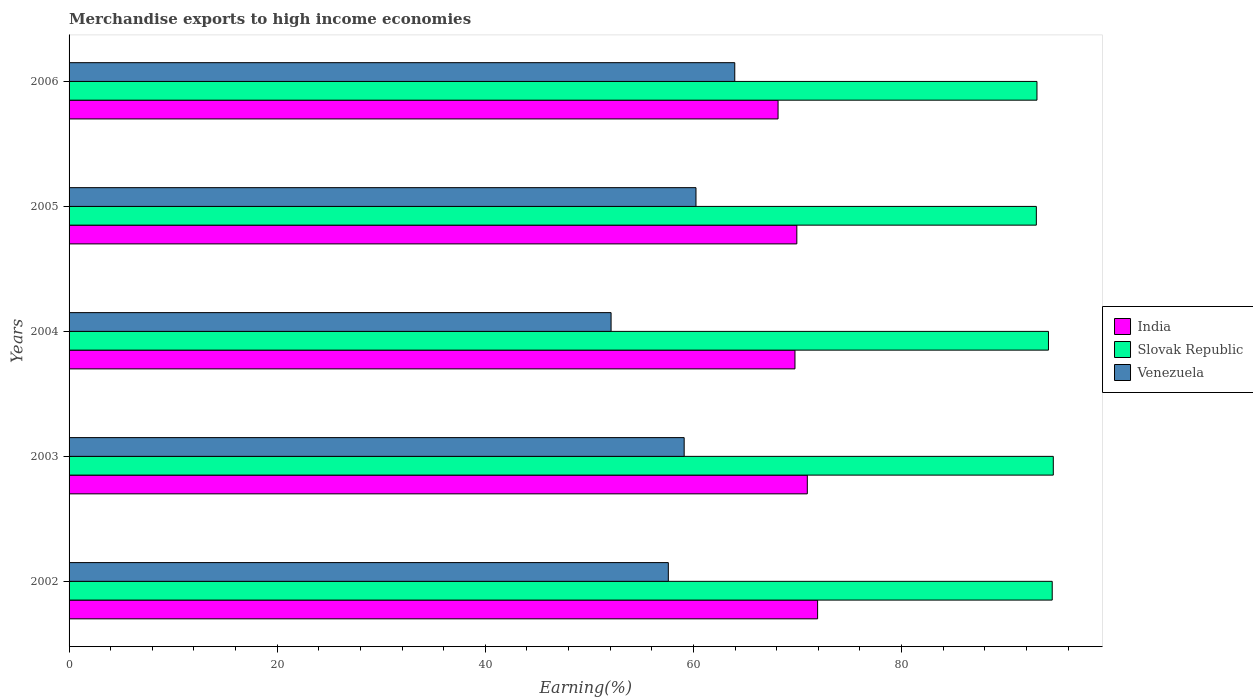Are the number of bars on each tick of the Y-axis equal?
Your answer should be compact. Yes. How many bars are there on the 2nd tick from the top?
Give a very brief answer. 3. What is the percentage of amount earned from merchandise exports in Venezuela in 2002?
Offer a very short reply. 57.59. Across all years, what is the maximum percentage of amount earned from merchandise exports in India?
Your response must be concise. 71.94. Across all years, what is the minimum percentage of amount earned from merchandise exports in Slovak Republic?
Your answer should be very brief. 92.96. What is the total percentage of amount earned from merchandise exports in Venezuela in the graph?
Offer a very short reply. 293.02. What is the difference between the percentage of amount earned from merchandise exports in India in 2003 and that in 2004?
Provide a succinct answer. 1.19. What is the difference between the percentage of amount earned from merchandise exports in Slovak Republic in 2004 and the percentage of amount earned from merchandise exports in Venezuela in 2003?
Your answer should be very brief. 35.01. What is the average percentage of amount earned from merchandise exports in India per year?
Offer a very short reply. 70.14. In the year 2004, what is the difference between the percentage of amount earned from merchandise exports in Slovak Republic and percentage of amount earned from merchandise exports in India?
Offer a terse response. 24.36. In how many years, is the percentage of amount earned from merchandise exports in Venezuela greater than 44 %?
Provide a succinct answer. 5. What is the ratio of the percentage of amount earned from merchandise exports in India in 2002 to that in 2005?
Make the answer very short. 1.03. Is the percentage of amount earned from merchandise exports in Slovak Republic in 2004 less than that in 2006?
Give a very brief answer. No. Is the difference between the percentage of amount earned from merchandise exports in Slovak Republic in 2003 and 2004 greater than the difference between the percentage of amount earned from merchandise exports in India in 2003 and 2004?
Offer a terse response. No. What is the difference between the highest and the second highest percentage of amount earned from merchandise exports in Slovak Republic?
Your response must be concise. 0.1. What is the difference between the highest and the lowest percentage of amount earned from merchandise exports in Slovak Republic?
Make the answer very short. 1.63. In how many years, is the percentage of amount earned from merchandise exports in Venezuela greater than the average percentage of amount earned from merchandise exports in Venezuela taken over all years?
Keep it short and to the point. 3. What does the 2nd bar from the top in 2004 represents?
Keep it short and to the point. Slovak Republic. How many bars are there?
Offer a very short reply. 15. Are all the bars in the graph horizontal?
Ensure brevity in your answer.  Yes. What is the difference between two consecutive major ticks on the X-axis?
Give a very brief answer. 20. Are the values on the major ticks of X-axis written in scientific E-notation?
Provide a succinct answer. No. Does the graph contain any zero values?
Offer a very short reply. No. Does the graph contain grids?
Your answer should be compact. No. How many legend labels are there?
Ensure brevity in your answer.  3. How are the legend labels stacked?
Provide a short and direct response. Vertical. What is the title of the graph?
Keep it short and to the point. Merchandise exports to high income economies. Does "Burundi" appear as one of the legend labels in the graph?
Keep it short and to the point. No. What is the label or title of the X-axis?
Provide a short and direct response. Earning(%). What is the Earning(%) in India in 2002?
Give a very brief answer. 71.94. What is the Earning(%) in Slovak Republic in 2002?
Make the answer very short. 94.48. What is the Earning(%) of Venezuela in 2002?
Your response must be concise. 57.59. What is the Earning(%) of India in 2003?
Your answer should be very brief. 70.95. What is the Earning(%) in Slovak Republic in 2003?
Keep it short and to the point. 94.59. What is the Earning(%) of Venezuela in 2003?
Your answer should be compact. 59.11. What is the Earning(%) of India in 2004?
Provide a succinct answer. 69.76. What is the Earning(%) of Slovak Republic in 2004?
Your answer should be very brief. 94.12. What is the Earning(%) of Venezuela in 2004?
Your answer should be very brief. 52.09. What is the Earning(%) of India in 2005?
Your answer should be very brief. 69.94. What is the Earning(%) in Slovak Republic in 2005?
Offer a very short reply. 92.96. What is the Earning(%) in Venezuela in 2005?
Provide a succinct answer. 60.25. What is the Earning(%) in India in 2006?
Keep it short and to the point. 68.14. What is the Earning(%) of Slovak Republic in 2006?
Your response must be concise. 93.02. What is the Earning(%) in Venezuela in 2006?
Provide a short and direct response. 63.98. Across all years, what is the maximum Earning(%) in India?
Offer a very short reply. 71.94. Across all years, what is the maximum Earning(%) of Slovak Republic?
Provide a short and direct response. 94.59. Across all years, what is the maximum Earning(%) in Venezuela?
Offer a terse response. 63.98. Across all years, what is the minimum Earning(%) of India?
Give a very brief answer. 68.14. Across all years, what is the minimum Earning(%) of Slovak Republic?
Keep it short and to the point. 92.96. Across all years, what is the minimum Earning(%) in Venezuela?
Your answer should be very brief. 52.09. What is the total Earning(%) of India in the graph?
Provide a short and direct response. 350.72. What is the total Earning(%) of Slovak Republic in the graph?
Give a very brief answer. 469.17. What is the total Earning(%) in Venezuela in the graph?
Your answer should be very brief. 293.02. What is the difference between the Earning(%) in India in 2002 and that in 2003?
Ensure brevity in your answer.  0.99. What is the difference between the Earning(%) of Slovak Republic in 2002 and that in 2003?
Your response must be concise. -0.1. What is the difference between the Earning(%) in Venezuela in 2002 and that in 2003?
Offer a terse response. -1.52. What is the difference between the Earning(%) in India in 2002 and that in 2004?
Your response must be concise. 2.18. What is the difference between the Earning(%) of Slovak Republic in 2002 and that in 2004?
Give a very brief answer. 0.36. What is the difference between the Earning(%) of Venezuela in 2002 and that in 2004?
Your response must be concise. 5.5. What is the difference between the Earning(%) of India in 2002 and that in 2005?
Offer a very short reply. 2. What is the difference between the Earning(%) of Slovak Republic in 2002 and that in 2005?
Provide a succinct answer. 1.53. What is the difference between the Earning(%) of Venezuela in 2002 and that in 2005?
Give a very brief answer. -2.66. What is the difference between the Earning(%) of India in 2002 and that in 2006?
Offer a very short reply. 3.8. What is the difference between the Earning(%) in Slovak Republic in 2002 and that in 2006?
Your answer should be compact. 1.47. What is the difference between the Earning(%) in Venezuela in 2002 and that in 2006?
Ensure brevity in your answer.  -6.39. What is the difference between the Earning(%) in India in 2003 and that in 2004?
Your response must be concise. 1.19. What is the difference between the Earning(%) in Slovak Republic in 2003 and that in 2004?
Ensure brevity in your answer.  0.46. What is the difference between the Earning(%) of Venezuela in 2003 and that in 2004?
Make the answer very short. 7.03. What is the difference between the Earning(%) of India in 2003 and that in 2005?
Provide a succinct answer. 1.01. What is the difference between the Earning(%) of Slovak Republic in 2003 and that in 2005?
Ensure brevity in your answer.  1.63. What is the difference between the Earning(%) in Venezuela in 2003 and that in 2005?
Keep it short and to the point. -1.13. What is the difference between the Earning(%) of India in 2003 and that in 2006?
Make the answer very short. 2.81. What is the difference between the Earning(%) in Slovak Republic in 2003 and that in 2006?
Keep it short and to the point. 1.57. What is the difference between the Earning(%) in Venezuela in 2003 and that in 2006?
Your answer should be compact. -4.86. What is the difference between the Earning(%) in India in 2004 and that in 2005?
Your answer should be compact. -0.18. What is the difference between the Earning(%) in Slovak Republic in 2004 and that in 2005?
Ensure brevity in your answer.  1.17. What is the difference between the Earning(%) in Venezuela in 2004 and that in 2005?
Your answer should be compact. -8.16. What is the difference between the Earning(%) of India in 2004 and that in 2006?
Your response must be concise. 1.62. What is the difference between the Earning(%) in Slovak Republic in 2004 and that in 2006?
Make the answer very short. 1.1. What is the difference between the Earning(%) in Venezuela in 2004 and that in 2006?
Ensure brevity in your answer.  -11.89. What is the difference between the Earning(%) in India in 2005 and that in 2006?
Keep it short and to the point. 1.8. What is the difference between the Earning(%) of Slovak Republic in 2005 and that in 2006?
Give a very brief answer. -0.06. What is the difference between the Earning(%) of Venezuela in 2005 and that in 2006?
Provide a short and direct response. -3.73. What is the difference between the Earning(%) of India in 2002 and the Earning(%) of Slovak Republic in 2003?
Keep it short and to the point. -22.65. What is the difference between the Earning(%) of India in 2002 and the Earning(%) of Venezuela in 2003?
Provide a succinct answer. 12.82. What is the difference between the Earning(%) of Slovak Republic in 2002 and the Earning(%) of Venezuela in 2003?
Provide a short and direct response. 35.37. What is the difference between the Earning(%) in India in 2002 and the Earning(%) in Slovak Republic in 2004?
Make the answer very short. -22.19. What is the difference between the Earning(%) of India in 2002 and the Earning(%) of Venezuela in 2004?
Provide a short and direct response. 19.85. What is the difference between the Earning(%) in Slovak Republic in 2002 and the Earning(%) in Venezuela in 2004?
Your answer should be compact. 42.4. What is the difference between the Earning(%) of India in 2002 and the Earning(%) of Slovak Republic in 2005?
Offer a very short reply. -21.02. What is the difference between the Earning(%) in India in 2002 and the Earning(%) in Venezuela in 2005?
Offer a very short reply. 11.69. What is the difference between the Earning(%) in Slovak Republic in 2002 and the Earning(%) in Venezuela in 2005?
Provide a succinct answer. 34.24. What is the difference between the Earning(%) of India in 2002 and the Earning(%) of Slovak Republic in 2006?
Provide a short and direct response. -21.08. What is the difference between the Earning(%) of India in 2002 and the Earning(%) of Venezuela in 2006?
Offer a very short reply. 7.96. What is the difference between the Earning(%) of Slovak Republic in 2002 and the Earning(%) of Venezuela in 2006?
Ensure brevity in your answer.  30.51. What is the difference between the Earning(%) in India in 2003 and the Earning(%) in Slovak Republic in 2004?
Provide a succinct answer. -23.18. What is the difference between the Earning(%) of India in 2003 and the Earning(%) of Venezuela in 2004?
Make the answer very short. 18.86. What is the difference between the Earning(%) in Slovak Republic in 2003 and the Earning(%) in Venezuela in 2004?
Make the answer very short. 42.5. What is the difference between the Earning(%) in India in 2003 and the Earning(%) in Slovak Republic in 2005?
Your response must be concise. -22.01. What is the difference between the Earning(%) in India in 2003 and the Earning(%) in Venezuela in 2005?
Provide a short and direct response. 10.7. What is the difference between the Earning(%) in Slovak Republic in 2003 and the Earning(%) in Venezuela in 2005?
Give a very brief answer. 34.34. What is the difference between the Earning(%) of India in 2003 and the Earning(%) of Slovak Republic in 2006?
Offer a terse response. -22.07. What is the difference between the Earning(%) of India in 2003 and the Earning(%) of Venezuela in 2006?
Offer a very short reply. 6.97. What is the difference between the Earning(%) of Slovak Republic in 2003 and the Earning(%) of Venezuela in 2006?
Give a very brief answer. 30.61. What is the difference between the Earning(%) of India in 2004 and the Earning(%) of Slovak Republic in 2005?
Make the answer very short. -23.2. What is the difference between the Earning(%) of India in 2004 and the Earning(%) of Venezuela in 2005?
Ensure brevity in your answer.  9.51. What is the difference between the Earning(%) of Slovak Republic in 2004 and the Earning(%) of Venezuela in 2005?
Offer a very short reply. 33.88. What is the difference between the Earning(%) in India in 2004 and the Earning(%) in Slovak Republic in 2006?
Keep it short and to the point. -23.26. What is the difference between the Earning(%) of India in 2004 and the Earning(%) of Venezuela in 2006?
Your answer should be compact. 5.78. What is the difference between the Earning(%) of Slovak Republic in 2004 and the Earning(%) of Venezuela in 2006?
Offer a terse response. 30.15. What is the difference between the Earning(%) of India in 2005 and the Earning(%) of Slovak Republic in 2006?
Give a very brief answer. -23.08. What is the difference between the Earning(%) of India in 2005 and the Earning(%) of Venezuela in 2006?
Your answer should be very brief. 5.96. What is the difference between the Earning(%) of Slovak Republic in 2005 and the Earning(%) of Venezuela in 2006?
Give a very brief answer. 28.98. What is the average Earning(%) in India per year?
Give a very brief answer. 70.14. What is the average Earning(%) of Slovak Republic per year?
Your answer should be very brief. 93.83. What is the average Earning(%) in Venezuela per year?
Your answer should be very brief. 58.6. In the year 2002, what is the difference between the Earning(%) in India and Earning(%) in Slovak Republic?
Provide a short and direct response. -22.55. In the year 2002, what is the difference between the Earning(%) in India and Earning(%) in Venezuela?
Offer a terse response. 14.35. In the year 2002, what is the difference between the Earning(%) in Slovak Republic and Earning(%) in Venezuela?
Provide a short and direct response. 36.89. In the year 2003, what is the difference between the Earning(%) in India and Earning(%) in Slovak Republic?
Give a very brief answer. -23.64. In the year 2003, what is the difference between the Earning(%) in India and Earning(%) in Venezuela?
Keep it short and to the point. 11.83. In the year 2003, what is the difference between the Earning(%) of Slovak Republic and Earning(%) of Venezuela?
Your answer should be very brief. 35.47. In the year 2004, what is the difference between the Earning(%) of India and Earning(%) of Slovak Republic?
Provide a short and direct response. -24.36. In the year 2004, what is the difference between the Earning(%) in India and Earning(%) in Venezuela?
Your answer should be compact. 17.67. In the year 2004, what is the difference between the Earning(%) of Slovak Republic and Earning(%) of Venezuela?
Offer a terse response. 42.03. In the year 2005, what is the difference between the Earning(%) in India and Earning(%) in Slovak Republic?
Your response must be concise. -23.02. In the year 2005, what is the difference between the Earning(%) in India and Earning(%) in Venezuela?
Provide a short and direct response. 9.69. In the year 2005, what is the difference between the Earning(%) of Slovak Republic and Earning(%) of Venezuela?
Provide a short and direct response. 32.71. In the year 2006, what is the difference between the Earning(%) in India and Earning(%) in Slovak Republic?
Your response must be concise. -24.88. In the year 2006, what is the difference between the Earning(%) of India and Earning(%) of Venezuela?
Provide a short and direct response. 4.16. In the year 2006, what is the difference between the Earning(%) in Slovak Republic and Earning(%) in Venezuela?
Keep it short and to the point. 29.04. What is the ratio of the Earning(%) in Venezuela in 2002 to that in 2003?
Offer a very short reply. 0.97. What is the ratio of the Earning(%) of India in 2002 to that in 2004?
Your response must be concise. 1.03. What is the ratio of the Earning(%) of Slovak Republic in 2002 to that in 2004?
Give a very brief answer. 1. What is the ratio of the Earning(%) in Venezuela in 2002 to that in 2004?
Offer a terse response. 1.11. What is the ratio of the Earning(%) in India in 2002 to that in 2005?
Offer a very short reply. 1.03. What is the ratio of the Earning(%) in Slovak Republic in 2002 to that in 2005?
Your response must be concise. 1.02. What is the ratio of the Earning(%) of Venezuela in 2002 to that in 2005?
Give a very brief answer. 0.96. What is the ratio of the Earning(%) of India in 2002 to that in 2006?
Your response must be concise. 1.06. What is the ratio of the Earning(%) of Slovak Republic in 2002 to that in 2006?
Ensure brevity in your answer.  1.02. What is the ratio of the Earning(%) in Venezuela in 2002 to that in 2006?
Your answer should be very brief. 0.9. What is the ratio of the Earning(%) in India in 2003 to that in 2004?
Make the answer very short. 1.02. What is the ratio of the Earning(%) in Slovak Republic in 2003 to that in 2004?
Your answer should be compact. 1. What is the ratio of the Earning(%) in Venezuela in 2003 to that in 2004?
Give a very brief answer. 1.13. What is the ratio of the Earning(%) in India in 2003 to that in 2005?
Keep it short and to the point. 1.01. What is the ratio of the Earning(%) in Slovak Republic in 2003 to that in 2005?
Your answer should be compact. 1.02. What is the ratio of the Earning(%) in Venezuela in 2003 to that in 2005?
Make the answer very short. 0.98. What is the ratio of the Earning(%) of India in 2003 to that in 2006?
Ensure brevity in your answer.  1.04. What is the ratio of the Earning(%) of Slovak Republic in 2003 to that in 2006?
Offer a terse response. 1.02. What is the ratio of the Earning(%) of Venezuela in 2003 to that in 2006?
Ensure brevity in your answer.  0.92. What is the ratio of the Earning(%) in India in 2004 to that in 2005?
Offer a terse response. 1. What is the ratio of the Earning(%) of Slovak Republic in 2004 to that in 2005?
Provide a short and direct response. 1.01. What is the ratio of the Earning(%) of Venezuela in 2004 to that in 2005?
Offer a very short reply. 0.86. What is the ratio of the Earning(%) in India in 2004 to that in 2006?
Give a very brief answer. 1.02. What is the ratio of the Earning(%) in Slovak Republic in 2004 to that in 2006?
Your answer should be very brief. 1.01. What is the ratio of the Earning(%) of Venezuela in 2004 to that in 2006?
Your response must be concise. 0.81. What is the ratio of the Earning(%) of India in 2005 to that in 2006?
Your response must be concise. 1.03. What is the ratio of the Earning(%) of Venezuela in 2005 to that in 2006?
Keep it short and to the point. 0.94. What is the difference between the highest and the second highest Earning(%) of India?
Give a very brief answer. 0.99. What is the difference between the highest and the second highest Earning(%) of Slovak Republic?
Give a very brief answer. 0.1. What is the difference between the highest and the second highest Earning(%) of Venezuela?
Your answer should be very brief. 3.73. What is the difference between the highest and the lowest Earning(%) of India?
Offer a very short reply. 3.8. What is the difference between the highest and the lowest Earning(%) of Slovak Republic?
Offer a terse response. 1.63. What is the difference between the highest and the lowest Earning(%) in Venezuela?
Offer a terse response. 11.89. 